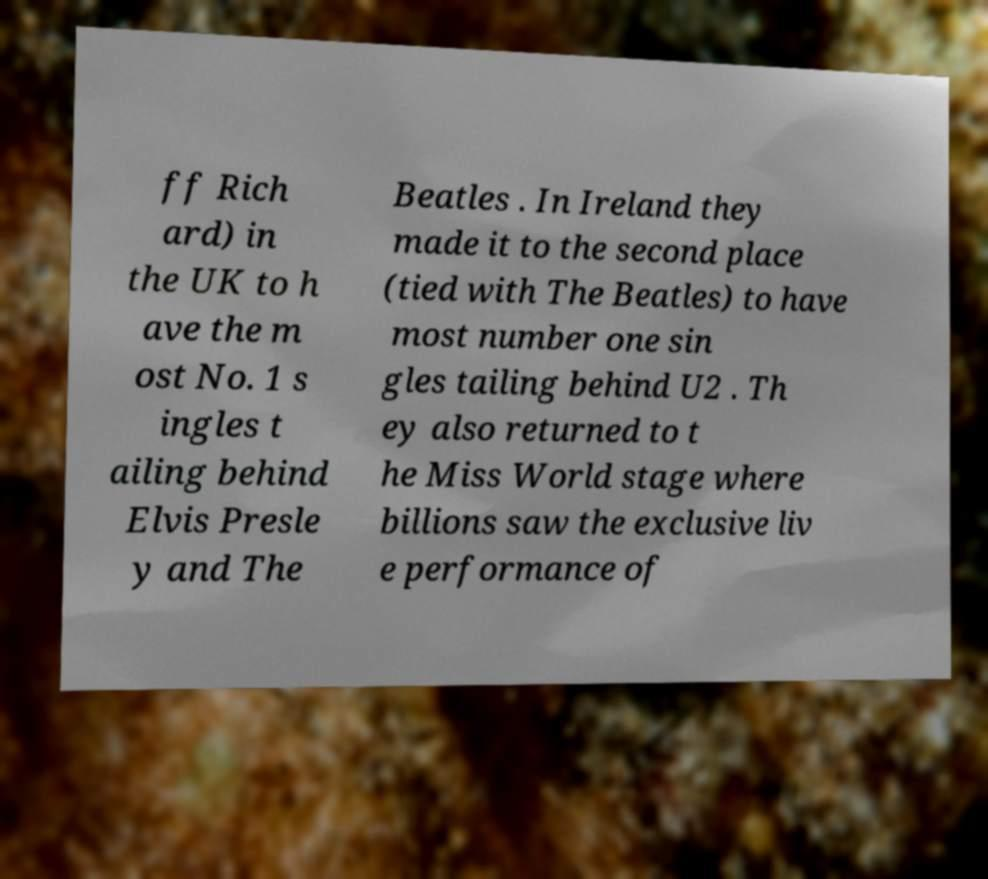Please identify and transcribe the text found in this image. ff Rich ard) in the UK to h ave the m ost No. 1 s ingles t ailing behind Elvis Presle y and The Beatles . In Ireland they made it to the second place (tied with The Beatles) to have most number one sin gles tailing behind U2 . Th ey also returned to t he Miss World stage where billions saw the exclusive liv e performance of 